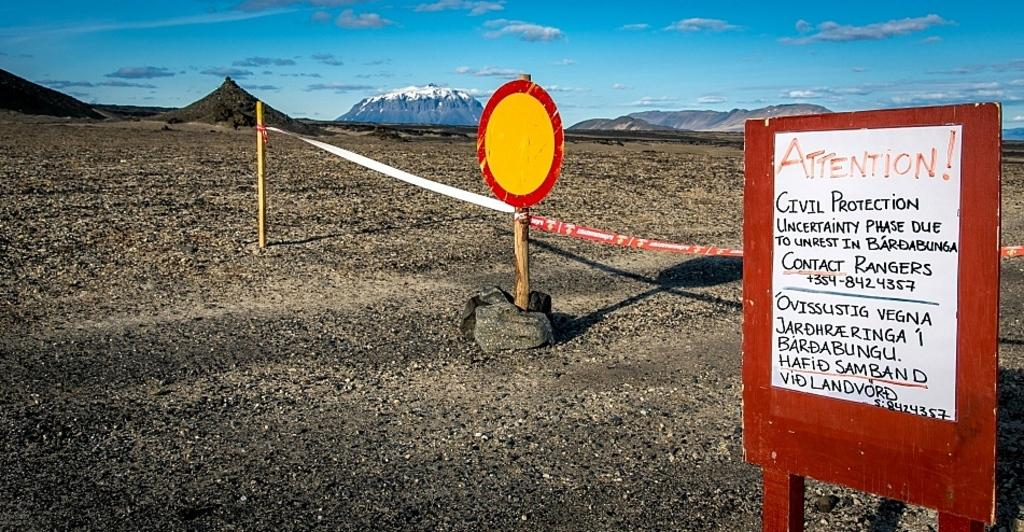<image>
Relay a brief, clear account of the picture shown. sign with attention civil protection on it next to round yellow sign and string blocking area 